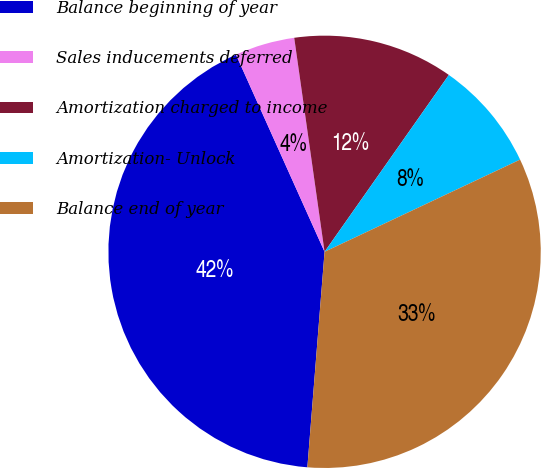<chart> <loc_0><loc_0><loc_500><loc_500><pie_chart><fcel>Balance beginning of year<fcel>Sales inducements deferred<fcel>Amortization charged to income<fcel>Amortization- Unlock<fcel>Balance end of year<nl><fcel>42.01%<fcel>4.48%<fcel>11.99%<fcel>8.24%<fcel>33.28%<nl></chart> 